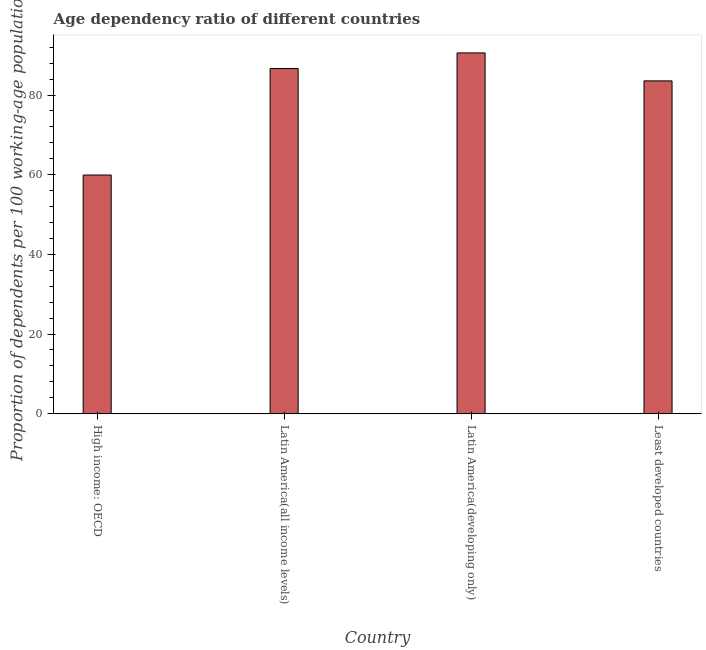Does the graph contain any zero values?
Keep it short and to the point. No. What is the title of the graph?
Provide a short and direct response. Age dependency ratio of different countries. What is the label or title of the Y-axis?
Your answer should be very brief. Proportion of dependents per 100 working-age population. What is the age dependency ratio in Latin America(all income levels)?
Provide a short and direct response. 86.65. Across all countries, what is the maximum age dependency ratio?
Keep it short and to the point. 90.56. Across all countries, what is the minimum age dependency ratio?
Your answer should be compact. 59.92. In which country was the age dependency ratio maximum?
Provide a short and direct response. Latin America(developing only). In which country was the age dependency ratio minimum?
Make the answer very short. High income: OECD. What is the sum of the age dependency ratio?
Your answer should be very brief. 320.67. What is the difference between the age dependency ratio in High income: OECD and Latin America(all income levels)?
Offer a very short reply. -26.73. What is the average age dependency ratio per country?
Your answer should be very brief. 80.17. What is the median age dependency ratio?
Provide a succinct answer. 85.1. What is the ratio of the age dependency ratio in High income: OECD to that in Latin America(developing only)?
Offer a very short reply. 0.66. Is the age dependency ratio in High income: OECD less than that in Latin America(all income levels)?
Give a very brief answer. Yes. What is the difference between the highest and the second highest age dependency ratio?
Provide a succinct answer. 3.92. Is the sum of the age dependency ratio in High income: OECD and Latin America(developing only) greater than the maximum age dependency ratio across all countries?
Your response must be concise. Yes. What is the difference between the highest and the lowest age dependency ratio?
Make the answer very short. 30.65. How many bars are there?
Make the answer very short. 4. What is the difference between two consecutive major ticks on the Y-axis?
Make the answer very short. 20. Are the values on the major ticks of Y-axis written in scientific E-notation?
Provide a succinct answer. No. What is the Proportion of dependents per 100 working-age population of High income: OECD?
Offer a terse response. 59.92. What is the Proportion of dependents per 100 working-age population in Latin America(all income levels)?
Offer a very short reply. 86.65. What is the Proportion of dependents per 100 working-age population of Latin America(developing only)?
Your answer should be very brief. 90.56. What is the Proportion of dependents per 100 working-age population of Least developed countries?
Provide a short and direct response. 83.55. What is the difference between the Proportion of dependents per 100 working-age population in High income: OECD and Latin America(all income levels)?
Give a very brief answer. -26.73. What is the difference between the Proportion of dependents per 100 working-age population in High income: OECD and Latin America(developing only)?
Give a very brief answer. -30.65. What is the difference between the Proportion of dependents per 100 working-age population in High income: OECD and Least developed countries?
Your answer should be compact. -23.63. What is the difference between the Proportion of dependents per 100 working-age population in Latin America(all income levels) and Latin America(developing only)?
Keep it short and to the point. -3.92. What is the difference between the Proportion of dependents per 100 working-age population in Latin America(all income levels) and Least developed countries?
Your answer should be very brief. 3.1. What is the difference between the Proportion of dependents per 100 working-age population in Latin America(developing only) and Least developed countries?
Your answer should be compact. 7.02. What is the ratio of the Proportion of dependents per 100 working-age population in High income: OECD to that in Latin America(all income levels)?
Give a very brief answer. 0.69. What is the ratio of the Proportion of dependents per 100 working-age population in High income: OECD to that in Latin America(developing only)?
Offer a very short reply. 0.66. What is the ratio of the Proportion of dependents per 100 working-age population in High income: OECD to that in Least developed countries?
Ensure brevity in your answer.  0.72. What is the ratio of the Proportion of dependents per 100 working-age population in Latin America(developing only) to that in Least developed countries?
Make the answer very short. 1.08. 